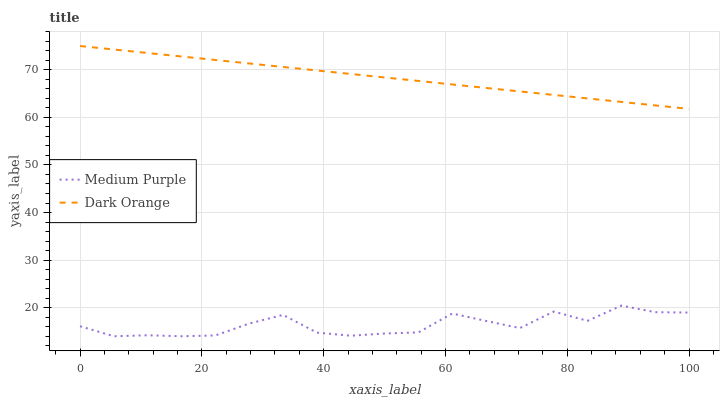Does Medium Purple have the minimum area under the curve?
Answer yes or no. Yes. Does Dark Orange have the maximum area under the curve?
Answer yes or no. Yes. Does Dark Orange have the minimum area under the curve?
Answer yes or no. No. Is Dark Orange the smoothest?
Answer yes or no. Yes. Is Medium Purple the roughest?
Answer yes or no. Yes. Is Dark Orange the roughest?
Answer yes or no. No. Does Dark Orange have the lowest value?
Answer yes or no. No. Does Dark Orange have the highest value?
Answer yes or no. Yes. Is Medium Purple less than Dark Orange?
Answer yes or no. Yes. Is Dark Orange greater than Medium Purple?
Answer yes or no. Yes. Does Medium Purple intersect Dark Orange?
Answer yes or no. No. 